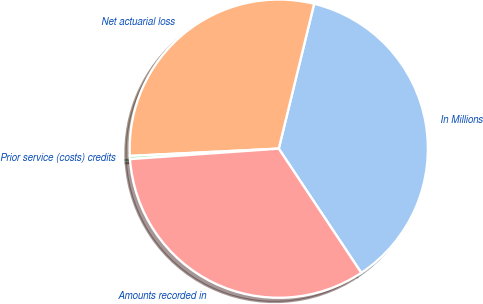<chart> <loc_0><loc_0><loc_500><loc_500><pie_chart><fcel>In Millions<fcel>Net actuarial loss<fcel>Prior service (costs) credits<fcel>Amounts recorded in<nl><fcel>36.85%<fcel>29.59%<fcel>0.34%<fcel>33.22%<nl></chart> 